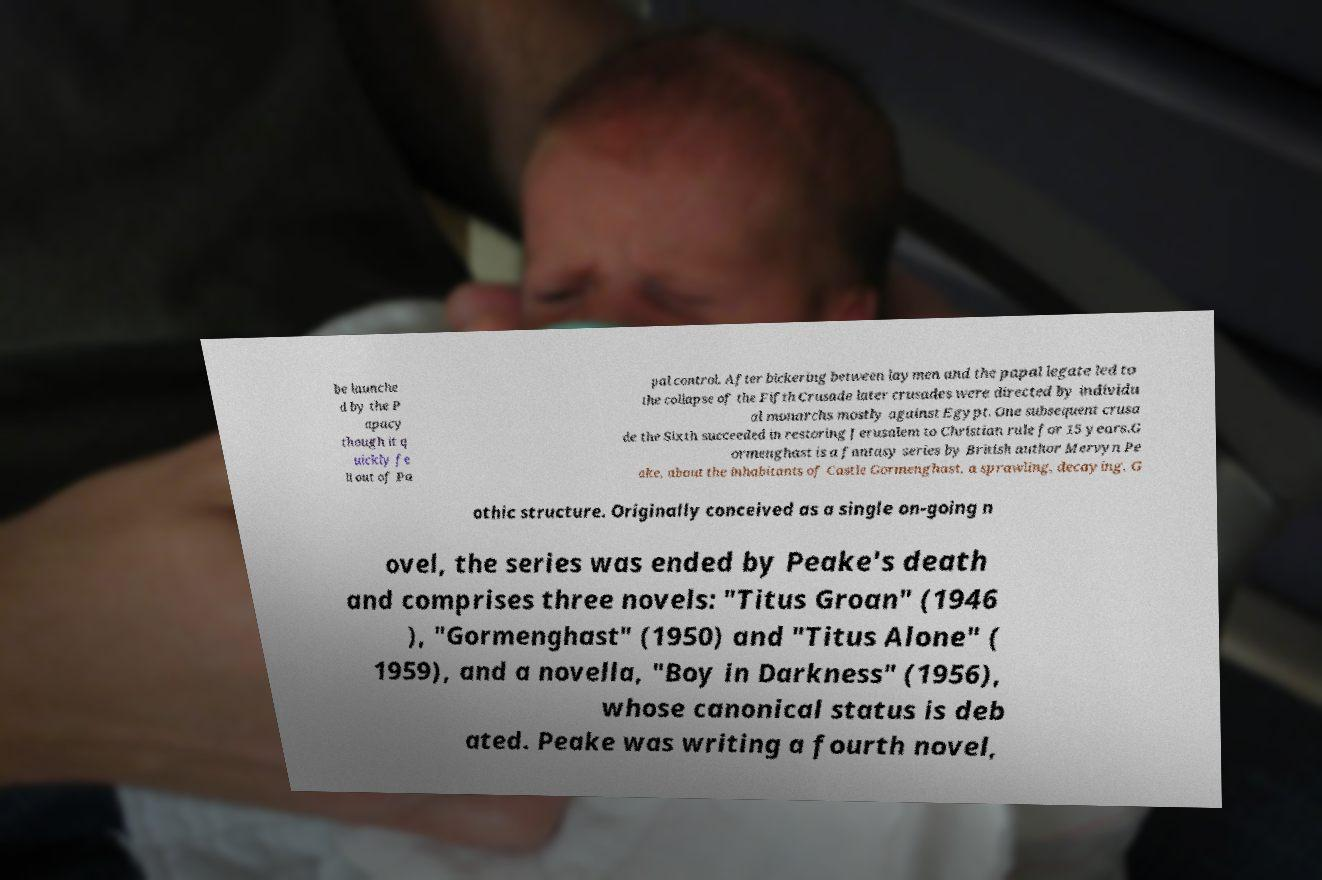Please read and relay the text visible in this image. What does it say? be launche d by the P apacy though it q uickly fe ll out of Pa pal control. After bickering between laymen and the papal legate led to the collapse of the Fifth Crusade later crusades were directed by individu al monarchs mostly against Egypt. One subsequent crusa de the Sixth succeeded in restoring Jerusalem to Christian rule for 15 years.G ormenghast is a fantasy series by British author Mervyn Pe ake, about the inhabitants of Castle Gormenghast, a sprawling, decaying, G othic structure. Originally conceived as a single on-going n ovel, the series was ended by Peake's death and comprises three novels: "Titus Groan" (1946 ), "Gormenghast" (1950) and "Titus Alone" ( 1959), and a novella, "Boy in Darkness" (1956), whose canonical status is deb ated. Peake was writing a fourth novel, 